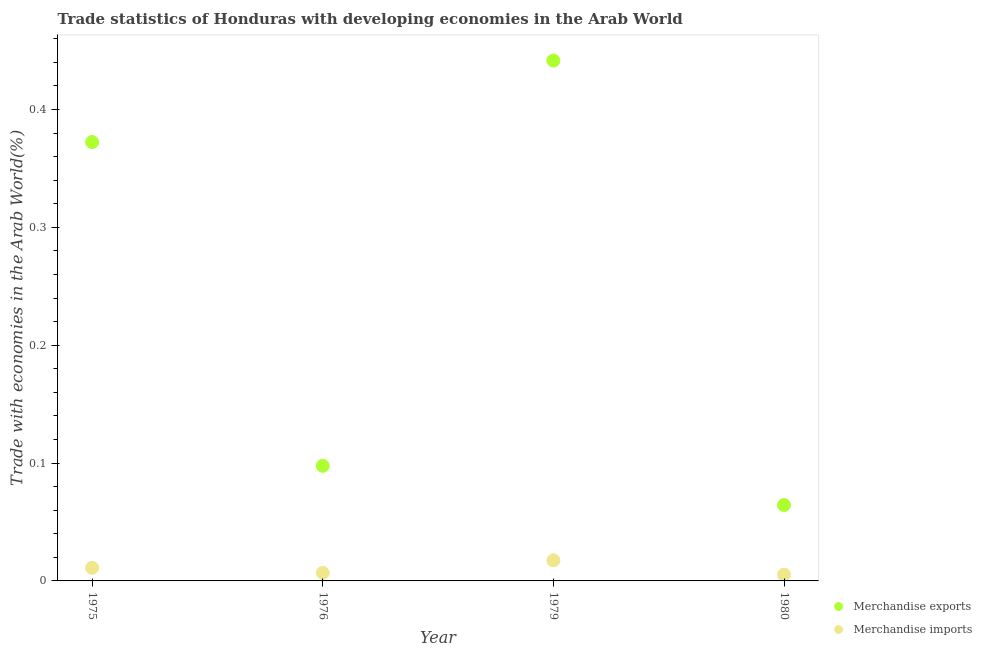How many different coloured dotlines are there?
Offer a very short reply. 2. Is the number of dotlines equal to the number of legend labels?
Provide a succinct answer. Yes. What is the merchandise exports in 1975?
Provide a short and direct response. 0.37. Across all years, what is the maximum merchandise exports?
Offer a very short reply. 0.44. Across all years, what is the minimum merchandise imports?
Make the answer very short. 0.01. In which year was the merchandise imports maximum?
Provide a short and direct response. 1979. In which year was the merchandise imports minimum?
Offer a very short reply. 1980. What is the total merchandise exports in the graph?
Keep it short and to the point. 0.98. What is the difference between the merchandise exports in 1979 and that in 1980?
Keep it short and to the point. 0.38. What is the difference between the merchandise exports in 1979 and the merchandise imports in 1980?
Your answer should be compact. 0.44. What is the average merchandise imports per year?
Provide a succinct answer. 0.01. In the year 1975, what is the difference between the merchandise imports and merchandise exports?
Your answer should be compact. -0.36. What is the ratio of the merchandise imports in 1979 to that in 1980?
Your response must be concise. 3.25. What is the difference between the highest and the second highest merchandise imports?
Provide a short and direct response. 0.01. What is the difference between the highest and the lowest merchandise exports?
Your answer should be very brief. 0.38. Is the sum of the merchandise imports in 1975 and 1979 greater than the maximum merchandise exports across all years?
Offer a very short reply. No. Is the merchandise imports strictly less than the merchandise exports over the years?
Keep it short and to the point. Yes. How many dotlines are there?
Provide a succinct answer. 2. Are the values on the major ticks of Y-axis written in scientific E-notation?
Your response must be concise. No. How many legend labels are there?
Provide a succinct answer. 2. How are the legend labels stacked?
Give a very brief answer. Vertical. What is the title of the graph?
Offer a terse response. Trade statistics of Honduras with developing economies in the Arab World. What is the label or title of the X-axis?
Make the answer very short. Year. What is the label or title of the Y-axis?
Your answer should be compact. Trade with economies in the Arab World(%). What is the Trade with economies in the Arab World(%) of Merchandise exports in 1975?
Provide a succinct answer. 0.37. What is the Trade with economies in the Arab World(%) of Merchandise imports in 1975?
Ensure brevity in your answer.  0.01. What is the Trade with economies in the Arab World(%) of Merchandise exports in 1976?
Provide a short and direct response. 0.1. What is the Trade with economies in the Arab World(%) of Merchandise imports in 1976?
Your response must be concise. 0.01. What is the Trade with economies in the Arab World(%) in Merchandise exports in 1979?
Ensure brevity in your answer.  0.44. What is the Trade with economies in the Arab World(%) in Merchandise imports in 1979?
Offer a terse response. 0.02. What is the Trade with economies in the Arab World(%) in Merchandise exports in 1980?
Keep it short and to the point. 0.06. What is the Trade with economies in the Arab World(%) in Merchandise imports in 1980?
Offer a terse response. 0.01. Across all years, what is the maximum Trade with economies in the Arab World(%) of Merchandise exports?
Your response must be concise. 0.44. Across all years, what is the maximum Trade with economies in the Arab World(%) in Merchandise imports?
Ensure brevity in your answer.  0.02. Across all years, what is the minimum Trade with economies in the Arab World(%) in Merchandise exports?
Your answer should be very brief. 0.06. Across all years, what is the minimum Trade with economies in the Arab World(%) in Merchandise imports?
Ensure brevity in your answer.  0.01. What is the total Trade with economies in the Arab World(%) in Merchandise imports in the graph?
Your answer should be very brief. 0.04. What is the difference between the Trade with economies in the Arab World(%) of Merchandise exports in 1975 and that in 1976?
Your response must be concise. 0.27. What is the difference between the Trade with economies in the Arab World(%) in Merchandise imports in 1975 and that in 1976?
Provide a short and direct response. 0. What is the difference between the Trade with economies in the Arab World(%) of Merchandise exports in 1975 and that in 1979?
Give a very brief answer. -0.07. What is the difference between the Trade with economies in the Arab World(%) in Merchandise imports in 1975 and that in 1979?
Keep it short and to the point. -0.01. What is the difference between the Trade with economies in the Arab World(%) in Merchandise exports in 1975 and that in 1980?
Provide a short and direct response. 0.31. What is the difference between the Trade with economies in the Arab World(%) of Merchandise imports in 1975 and that in 1980?
Make the answer very short. 0.01. What is the difference between the Trade with economies in the Arab World(%) of Merchandise exports in 1976 and that in 1979?
Offer a very short reply. -0.34. What is the difference between the Trade with economies in the Arab World(%) of Merchandise imports in 1976 and that in 1979?
Offer a very short reply. -0.01. What is the difference between the Trade with economies in the Arab World(%) of Merchandise imports in 1976 and that in 1980?
Keep it short and to the point. 0. What is the difference between the Trade with economies in the Arab World(%) in Merchandise exports in 1979 and that in 1980?
Keep it short and to the point. 0.38. What is the difference between the Trade with economies in the Arab World(%) in Merchandise imports in 1979 and that in 1980?
Your answer should be very brief. 0.01. What is the difference between the Trade with economies in the Arab World(%) in Merchandise exports in 1975 and the Trade with economies in the Arab World(%) in Merchandise imports in 1976?
Offer a very short reply. 0.37. What is the difference between the Trade with economies in the Arab World(%) in Merchandise exports in 1975 and the Trade with economies in the Arab World(%) in Merchandise imports in 1979?
Give a very brief answer. 0.35. What is the difference between the Trade with economies in the Arab World(%) of Merchandise exports in 1975 and the Trade with economies in the Arab World(%) of Merchandise imports in 1980?
Give a very brief answer. 0.37. What is the difference between the Trade with economies in the Arab World(%) of Merchandise exports in 1976 and the Trade with economies in the Arab World(%) of Merchandise imports in 1979?
Ensure brevity in your answer.  0.08. What is the difference between the Trade with economies in the Arab World(%) in Merchandise exports in 1976 and the Trade with economies in the Arab World(%) in Merchandise imports in 1980?
Provide a short and direct response. 0.09. What is the difference between the Trade with economies in the Arab World(%) of Merchandise exports in 1979 and the Trade with economies in the Arab World(%) of Merchandise imports in 1980?
Make the answer very short. 0.44. What is the average Trade with economies in the Arab World(%) in Merchandise exports per year?
Keep it short and to the point. 0.24. What is the average Trade with economies in the Arab World(%) of Merchandise imports per year?
Make the answer very short. 0.01. In the year 1975, what is the difference between the Trade with economies in the Arab World(%) of Merchandise exports and Trade with economies in the Arab World(%) of Merchandise imports?
Your answer should be compact. 0.36. In the year 1976, what is the difference between the Trade with economies in the Arab World(%) in Merchandise exports and Trade with economies in the Arab World(%) in Merchandise imports?
Give a very brief answer. 0.09. In the year 1979, what is the difference between the Trade with economies in the Arab World(%) in Merchandise exports and Trade with economies in the Arab World(%) in Merchandise imports?
Your answer should be very brief. 0.42. In the year 1980, what is the difference between the Trade with economies in the Arab World(%) in Merchandise exports and Trade with economies in the Arab World(%) in Merchandise imports?
Your response must be concise. 0.06. What is the ratio of the Trade with economies in the Arab World(%) in Merchandise exports in 1975 to that in 1976?
Offer a very short reply. 3.81. What is the ratio of the Trade with economies in the Arab World(%) of Merchandise imports in 1975 to that in 1976?
Your response must be concise. 1.63. What is the ratio of the Trade with economies in the Arab World(%) of Merchandise exports in 1975 to that in 1979?
Keep it short and to the point. 0.84. What is the ratio of the Trade with economies in the Arab World(%) of Merchandise imports in 1975 to that in 1979?
Offer a very short reply. 0.64. What is the ratio of the Trade with economies in the Arab World(%) of Merchandise exports in 1975 to that in 1980?
Your answer should be very brief. 5.78. What is the ratio of the Trade with economies in the Arab World(%) of Merchandise imports in 1975 to that in 1980?
Provide a short and direct response. 2.07. What is the ratio of the Trade with economies in the Arab World(%) in Merchandise exports in 1976 to that in 1979?
Keep it short and to the point. 0.22. What is the ratio of the Trade with economies in the Arab World(%) in Merchandise imports in 1976 to that in 1979?
Give a very brief answer. 0.39. What is the ratio of the Trade with economies in the Arab World(%) in Merchandise exports in 1976 to that in 1980?
Give a very brief answer. 1.52. What is the ratio of the Trade with economies in the Arab World(%) in Merchandise imports in 1976 to that in 1980?
Offer a very short reply. 1.27. What is the ratio of the Trade with economies in the Arab World(%) of Merchandise exports in 1979 to that in 1980?
Your response must be concise. 6.86. What is the ratio of the Trade with economies in the Arab World(%) in Merchandise imports in 1979 to that in 1980?
Keep it short and to the point. 3.25. What is the difference between the highest and the second highest Trade with economies in the Arab World(%) in Merchandise exports?
Your answer should be very brief. 0.07. What is the difference between the highest and the second highest Trade with economies in the Arab World(%) in Merchandise imports?
Make the answer very short. 0.01. What is the difference between the highest and the lowest Trade with economies in the Arab World(%) of Merchandise exports?
Make the answer very short. 0.38. What is the difference between the highest and the lowest Trade with economies in the Arab World(%) of Merchandise imports?
Offer a terse response. 0.01. 